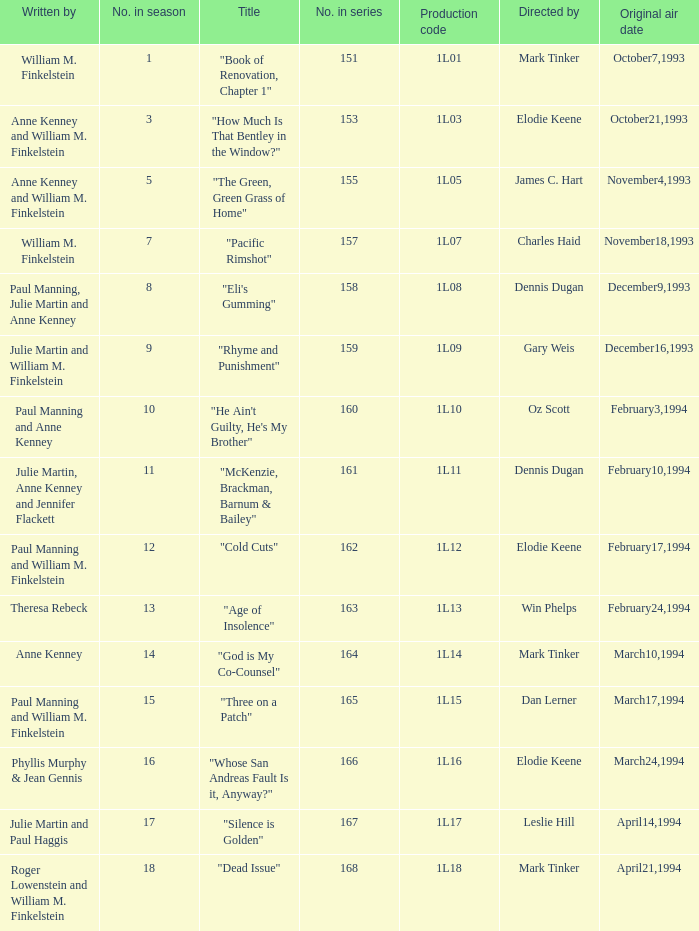Name the most number in season for leslie hill 17.0. 